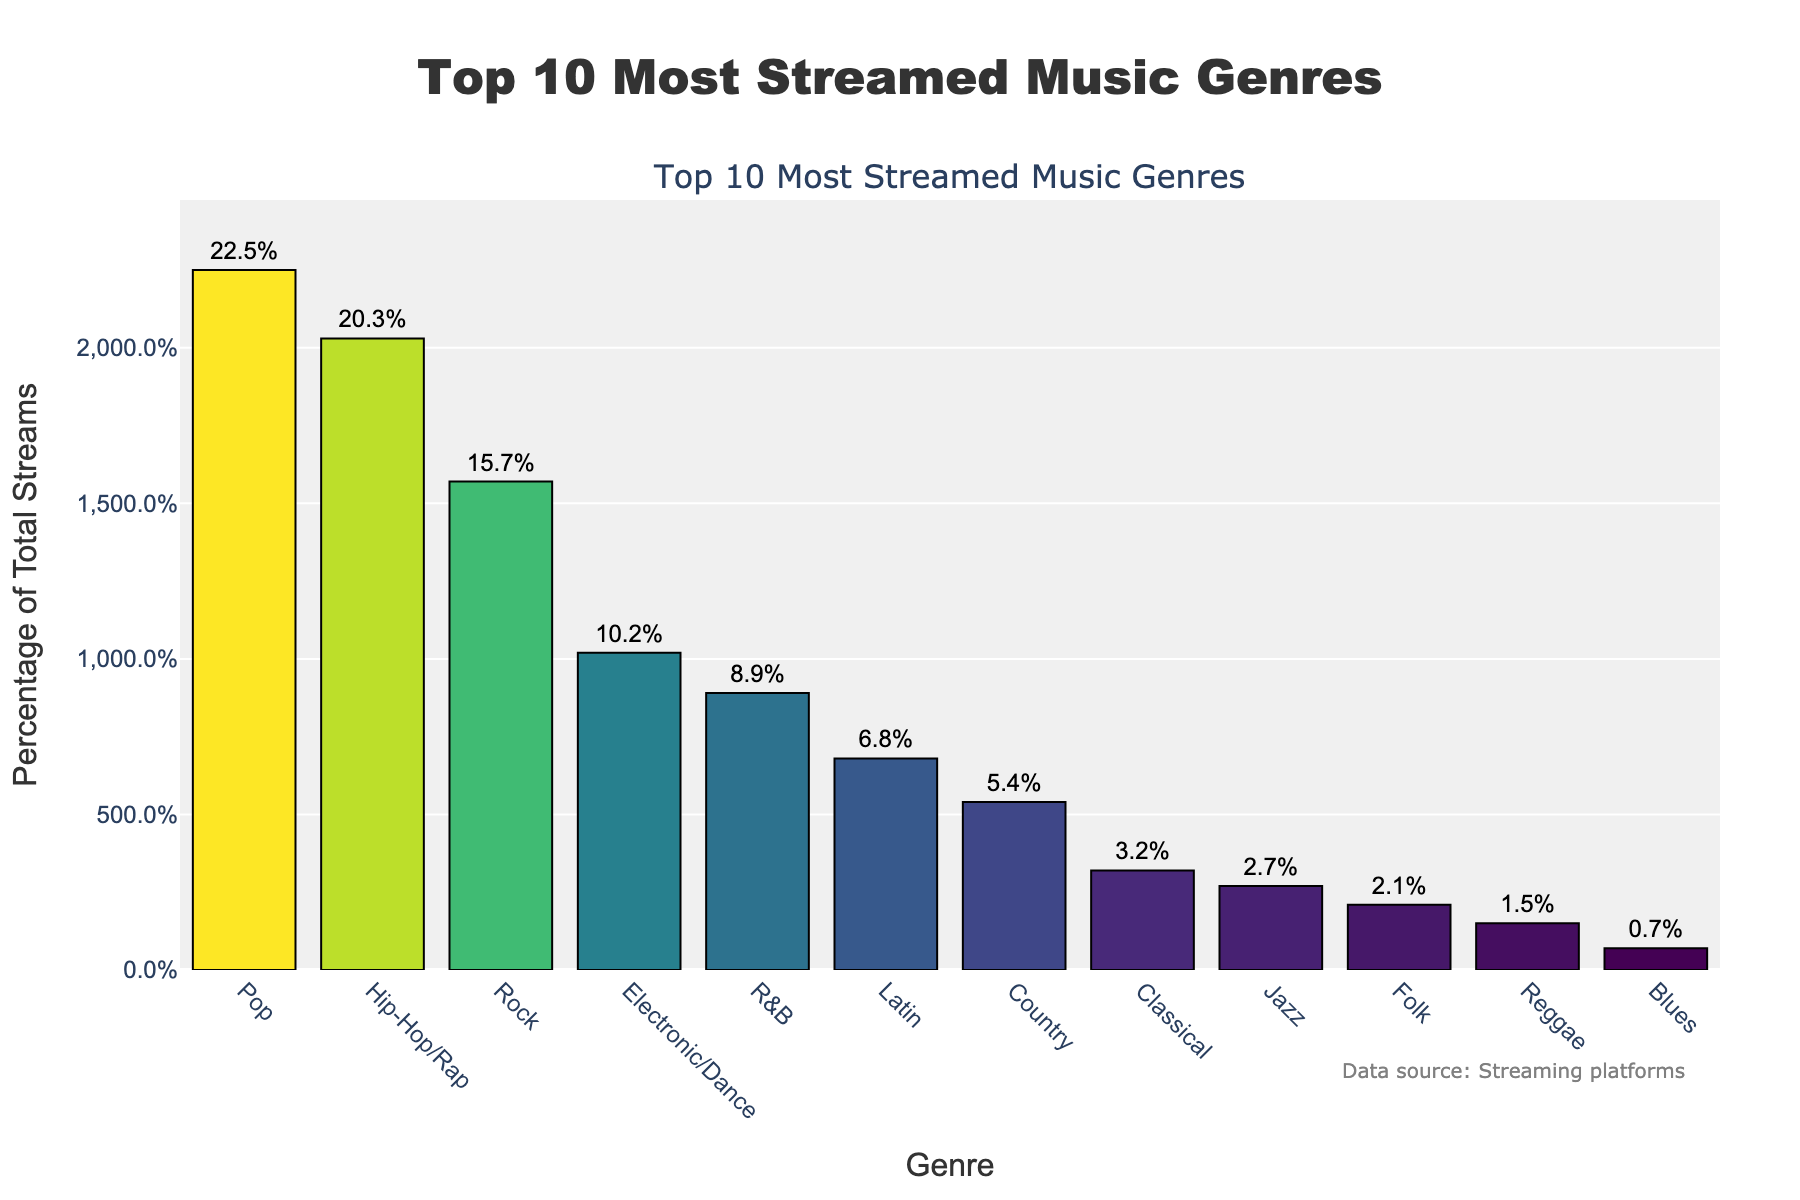Which genre has the highest percentage of total streams? The bar chart shows that the genre "Pop" has the tallest bar, indicating it has the highest percentage of total streams at 22.5%.
Answer: Pop How much higher is the percentage of Pop streams compared to Classical streams? The Pop genre has 22.5% of total streams, while the Classical genre has 3.2%. The difference is calculated by subtracting the percentage of Classical streams from the percentage of Pop streams: 22.5% - 3.2% = 19.3%.
Answer: 19.3% Which genre has the lowest percentage of streams, and what is its percentage? The shortest bar on the bar chart belongs to the Blues genre, indicating it has the lowest percentage of total streams at 0.7%.
Answer: Blues, 0.7% How does the percentage of Hip-Hop/Rap streams compare with that of Country streams? The percentage of Hip-Hop/Rap streams is 20.3%, while the percentage of Country streams is 5.4%. Since 20.3% is greater than 5.4%, Hip-Hop/Rap has a higher percentage of total streams compared to Country.
Answer: Hip-Hop/Rap has a higher percentage What are the top three genres by percentage of total streams? According to the bar chart, the top three genres by percentage of total streams are Pop (22.5%), Hip-Hop/Rap (20.3%), and Rock (15.7%).
Answer: Pop, Hip-Hop/Rap, Rock What is the combined percentage of streams for Latin, Jazz, and Folk genres? The percentages for Latin, Jazz, and Folk genres are 6.8%, 2.7%, and 2.1%, respectively. Adding these together gives 6.8% + 2.7% + 2.1% = 11.6%.
Answer: 11.6% Compare the percentage of Electronic/Dance streams to the sum of Classical and Folk streams. Electronic/Dance has a percentage of 10.2%. Classical streams are 3.2%, and Folk streams are 2.1%. The sum of Classical and Folk streams is 3.2% + 2.1% = 5.3%. Since 10.2% is greater than 5.3%, Electronic/Dance streams have a higher percentage.
Answer: Electronic/Dance is higher Which genres have a percentage of total streams less than 5%? According to the bar chart, genres with less than 5% of total streams are Classical (3.2%), Jazz (2.7%), Folk (2.1%), Reggae (1.5%), and Blues (0.7%).
Answer: Classical, Jazz, Folk, Reggae, Blues 